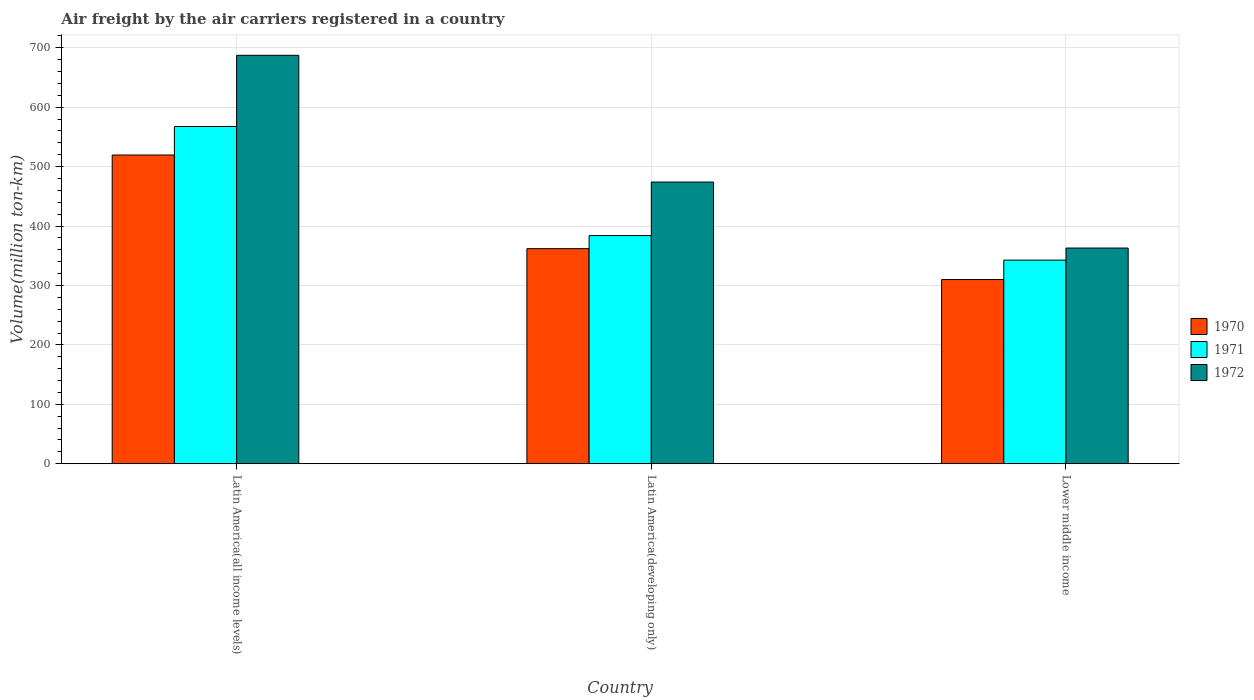How many groups of bars are there?
Provide a succinct answer. 3. What is the label of the 1st group of bars from the left?
Make the answer very short. Latin America(all income levels). In how many cases, is the number of bars for a given country not equal to the number of legend labels?
Provide a succinct answer. 0. What is the volume of the air carriers in 1971 in Lower middle income?
Your answer should be compact. 342.7. Across all countries, what is the maximum volume of the air carriers in 1971?
Keep it short and to the point. 567.6. Across all countries, what is the minimum volume of the air carriers in 1971?
Keep it short and to the point. 342.7. In which country was the volume of the air carriers in 1972 maximum?
Provide a short and direct response. Latin America(all income levels). In which country was the volume of the air carriers in 1972 minimum?
Ensure brevity in your answer.  Lower middle income. What is the total volume of the air carriers in 1971 in the graph?
Ensure brevity in your answer.  1294.3. What is the difference between the volume of the air carriers in 1972 in Latin America(all income levels) and that in Latin America(developing only)?
Your answer should be compact. 213.3. What is the difference between the volume of the air carriers in 1972 in Latin America(all income levels) and the volume of the air carriers in 1970 in Latin America(developing only)?
Your response must be concise. 325.4. What is the average volume of the air carriers in 1970 per country?
Make the answer very short. 397.2. What is the difference between the volume of the air carriers of/in 1970 and volume of the air carriers of/in 1972 in Lower middle income?
Your answer should be very brief. -53. What is the ratio of the volume of the air carriers in 1970 in Latin America(developing only) to that in Lower middle income?
Give a very brief answer. 1.17. Is the volume of the air carriers in 1971 in Latin America(all income levels) less than that in Latin America(developing only)?
Your answer should be very brief. No. Is the difference between the volume of the air carriers in 1970 in Latin America(all income levels) and Lower middle income greater than the difference between the volume of the air carriers in 1972 in Latin America(all income levels) and Lower middle income?
Give a very brief answer. No. What is the difference between the highest and the second highest volume of the air carriers in 1972?
Your answer should be very brief. 111.1. What is the difference between the highest and the lowest volume of the air carriers in 1972?
Give a very brief answer. 324.4. Is the sum of the volume of the air carriers in 1970 in Latin America(all income levels) and Lower middle income greater than the maximum volume of the air carriers in 1971 across all countries?
Make the answer very short. Yes. Is it the case that in every country, the sum of the volume of the air carriers in 1971 and volume of the air carriers in 1972 is greater than the volume of the air carriers in 1970?
Give a very brief answer. Yes. How many bars are there?
Keep it short and to the point. 9. What is the difference between two consecutive major ticks on the Y-axis?
Keep it short and to the point. 100. Are the values on the major ticks of Y-axis written in scientific E-notation?
Provide a succinct answer. No. How are the legend labels stacked?
Make the answer very short. Vertical. What is the title of the graph?
Make the answer very short. Air freight by the air carriers registered in a country. What is the label or title of the Y-axis?
Ensure brevity in your answer.  Volume(million ton-km). What is the Volume(million ton-km) in 1970 in Latin America(all income levels)?
Offer a terse response. 519.6. What is the Volume(million ton-km) in 1971 in Latin America(all income levels)?
Provide a succinct answer. 567.6. What is the Volume(million ton-km) in 1972 in Latin America(all income levels)?
Ensure brevity in your answer.  687.4. What is the Volume(million ton-km) in 1970 in Latin America(developing only)?
Give a very brief answer. 362. What is the Volume(million ton-km) in 1971 in Latin America(developing only)?
Your answer should be very brief. 384. What is the Volume(million ton-km) of 1972 in Latin America(developing only)?
Offer a terse response. 474.1. What is the Volume(million ton-km) of 1970 in Lower middle income?
Keep it short and to the point. 310. What is the Volume(million ton-km) of 1971 in Lower middle income?
Offer a terse response. 342.7. What is the Volume(million ton-km) in 1972 in Lower middle income?
Ensure brevity in your answer.  363. Across all countries, what is the maximum Volume(million ton-km) in 1970?
Give a very brief answer. 519.6. Across all countries, what is the maximum Volume(million ton-km) of 1971?
Provide a succinct answer. 567.6. Across all countries, what is the maximum Volume(million ton-km) in 1972?
Keep it short and to the point. 687.4. Across all countries, what is the minimum Volume(million ton-km) of 1970?
Provide a succinct answer. 310. Across all countries, what is the minimum Volume(million ton-km) in 1971?
Keep it short and to the point. 342.7. Across all countries, what is the minimum Volume(million ton-km) in 1972?
Your answer should be very brief. 363. What is the total Volume(million ton-km) in 1970 in the graph?
Provide a short and direct response. 1191.6. What is the total Volume(million ton-km) of 1971 in the graph?
Ensure brevity in your answer.  1294.3. What is the total Volume(million ton-km) in 1972 in the graph?
Provide a succinct answer. 1524.5. What is the difference between the Volume(million ton-km) in 1970 in Latin America(all income levels) and that in Latin America(developing only)?
Provide a succinct answer. 157.6. What is the difference between the Volume(million ton-km) in 1971 in Latin America(all income levels) and that in Latin America(developing only)?
Keep it short and to the point. 183.6. What is the difference between the Volume(million ton-km) of 1972 in Latin America(all income levels) and that in Latin America(developing only)?
Ensure brevity in your answer.  213.3. What is the difference between the Volume(million ton-km) of 1970 in Latin America(all income levels) and that in Lower middle income?
Offer a very short reply. 209.6. What is the difference between the Volume(million ton-km) in 1971 in Latin America(all income levels) and that in Lower middle income?
Your answer should be compact. 224.9. What is the difference between the Volume(million ton-km) in 1972 in Latin America(all income levels) and that in Lower middle income?
Keep it short and to the point. 324.4. What is the difference between the Volume(million ton-km) of 1971 in Latin America(developing only) and that in Lower middle income?
Provide a short and direct response. 41.3. What is the difference between the Volume(million ton-km) of 1972 in Latin America(developing only) and that in Lower middle income?
Your answer should be compact. 111.1. What is the difference between the Volume(million ton-km) in 1970 in Latin America(all income levels) and the Volume(million ton-km) in 1971 in Latin America(developing only)?
Ensure brevity in your answer.  135.6. What is the difference between the Volume(million ton-km) in 1970 in Latin America(all income levels) and the Volume(million ton-km) in 1972 in Latin America(developing only)?
Offer a terse response. 45.5. What is the difference between the Volume(million ton-km) in 1971 in Latin America(all income levels) and the Volume(million ton-km) in 1972 in Latin America(developing only)?
Your answer should be compact. 93.5. What is the difference between the Volume(million ton-km) of 1970 in Latin America(all income levels) and the Volume(million ton-km) of 1971 in Lower middle income?
Keep it short and to the point. 176.9. What is the difference between the Volume(million ton-km) in 1970 in Latin America(all income levels) and the Volume(million ton-km) in 1972 in Lower middle income?
Give a very brief answer. 156.6. What is the difference between the Volume(million ton-km) of 1971 in Latin America(all income levels) and the Volume(million ton-km) of 1972 in Lower middle income?
Provide a succinct answer. 204.6. What is the difference between the Volume(million ton-km) in 1970 in Latin America(developing only) and the Volume(million ton-km) in 1971 in Lower middle income?
Offer a very short reply. 19.3. What is the average Volume(million ton-km) in 1970 per country?
Provide a short and direct response. 397.2. What is the average Volume(million ton-km) in 1971 per country?
Offer a terse response. 431.43. What is the average Volume(million ton-km) of 1972 per country?
Your answer should be very brief. 508.17. What is the difference between the Volume(million ton-km) of 1970 and Volume(million ton-km) of 1971 in Latin America(all income levels)?
Keep it short and to the point. -48. What is the difference between the Volume(million ton-km) in 1970 and Volume(million ton-km) in 1972 in Latin America(all income levels)?
Provide a short and direct response. -167.8. What is the difference between the Volume(million ton-km) in 1971 and Volume(million ton-km) in 1972 in Latin America(all income levels)?
Offer a terse response. -119.8. What is the difference between the Volume(million ton-km) in 1970 and Volume(million ton-km) in 1971 in Latin America(developing only)?
Ensure brevity in your answer.  -22. What is the difference between the Volume(million ton-km) of 1970 and Volume(million ton-km) of 1972 in Latin America(developing only)?
Keep it short and to the point. -112.1. What is the difference between the Volume(million ton-km) of 1971 and Volume(million ton-km) of 1972 in Latin America(developing only)?
Keep it short and to the point. -90.1. What is the difference between the Volume(million ton-km) of 1970 and Volume(million ton-km) of 1971 in Lower middle income?
Provide a short and direct response. -32.7. What is the difference between the Volume(million ton-km) of 1970 and Volume(million ton-km) of 1972 in Lower middle income?
Offer a very short reply. -53. What is the difference between the Volume(million ton-km) of 1971 and Volume(million ton-km) of 1972 in Lower middle income?
Your answer should be compact. -20.3. What is the ratio of the Volume(million ton-km) in 1970 in Latin America(all income levels) to that in Latin America(developing only)?
Make the answer very short. 1.44. What is the ratio of the Volume(million ton-km) in 1971 in Latin America(all income levels) to that in Latin America(developing only)?
Offer a terse response. 1.48. What is the ratio of the Volume(million ton-km) in 1972 in Latin America(all income levels) to that in Latin America(developing only)?
Give a very brief answer. 1.45. What is the ratio of the Volume(million ton-km) in 1970 in Latin America(all income levels) to that in Lower middle income?
Provide a succinct answer. 1.68. What is the ratio of the Volume(million ton-km) of 1971 in Latin America(all income levels) to that in Lower middle income?
Your answer should be compact. 1.66. What is the ratio of the Volume(million ton-km) in 1972 in Latin America(all income levels) to that in Lower middle income?
Your answer should be very brief. 1.89. What is the ratio of the Volume(million ton-km) in 1970 in Latin America(developing only) to that in Lower middle income?
Your answer should be very brief. 1.17. What is the ratio of the Volume(million ton-km) of 1971 in Latin America(developing only) to that in Lower middle income?
Ensure brevity in your answer.  1.12. What is the ratio of the Volume(million ton-km) of 1972 in Latin America(developing only) to that in Lower middle income?
Give a very brief answer. 1.31. What is the difference between the highest and the second highest Volume(million ton-km) in 1970?
Provide a short and direct response. 157.6. What is the difference between the highest and the second highest Volume(million ton-km) of 1971?
Your answer should be very brief. 183.6. What is the difference between the highest and the second highest Volume(million ton-km) in 1972?
Keep it short and to the point. 213.3. What is the difference between the highest and the lowest Volume(million ton-km) in 1970?
Provide a short and direct response. 209.6. What is the difference between the highest and the lowest Volume(million ton-km) of 1971?
Keep it short and to the point. 224.9. What is the difference between the highest and the lowest Volume(million ton-km) of 1972?
Your response must be concise. 324.4. 